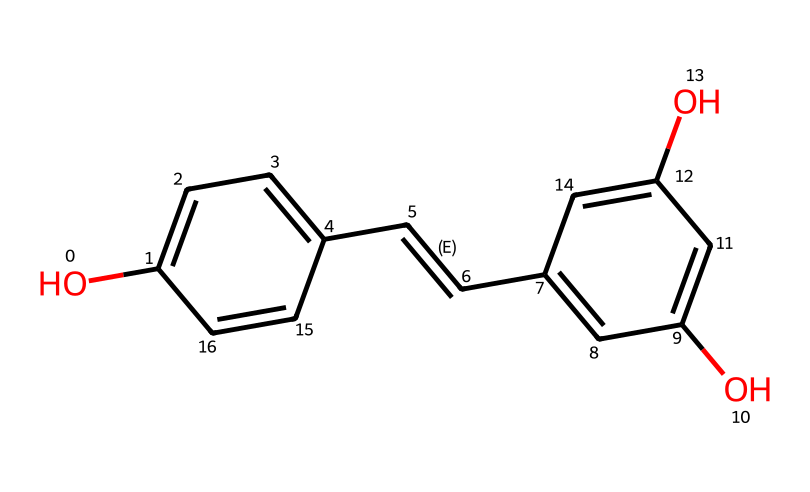What is the name of this compound? The SMILES representation corresponds to resveratrol, a well-known compound found in red wine. By analyzing the structure, it contains specific features indicative of its identity, such as hydroxyl groups and a trans double bond.
Answer: resveratrol How many carbon atoms are in the structure? By examining the SMILES, we can count the carbon atoms present within the structure (c1, c2, and other 'c' designators). There are specifically 14 carbon atoms visible in the SMILES description.
Answer: 14 How many hydroxyl (OH) groups are present? The 'O' entries in the SMILES representation indicate where hydroxyl groups are present. There are three 'O' entries in total, corresponding to three hydroxyl groups attached to the benzene rings in resveratrol.
Answer: 3 What is the molecular formula of resveratrol? By calculating the total number of each type of atom represented in the structure (C, H, and O), we can derive the molecular formula: C14H12O3, detailing 14 carbons, 12 hydrogens, and 3 oxygens.
Answer: C14H12O3 What type of antioxidant is resveratrol classified as? Resveratrol is classified as a polyphenolic antioxidant due to its multiple phenolic structures and antioxidant properties. It has a unique configuration allowing it to function as an antioxidant by scavenging free radicals.
Answer: polyphenolic antioxidant 